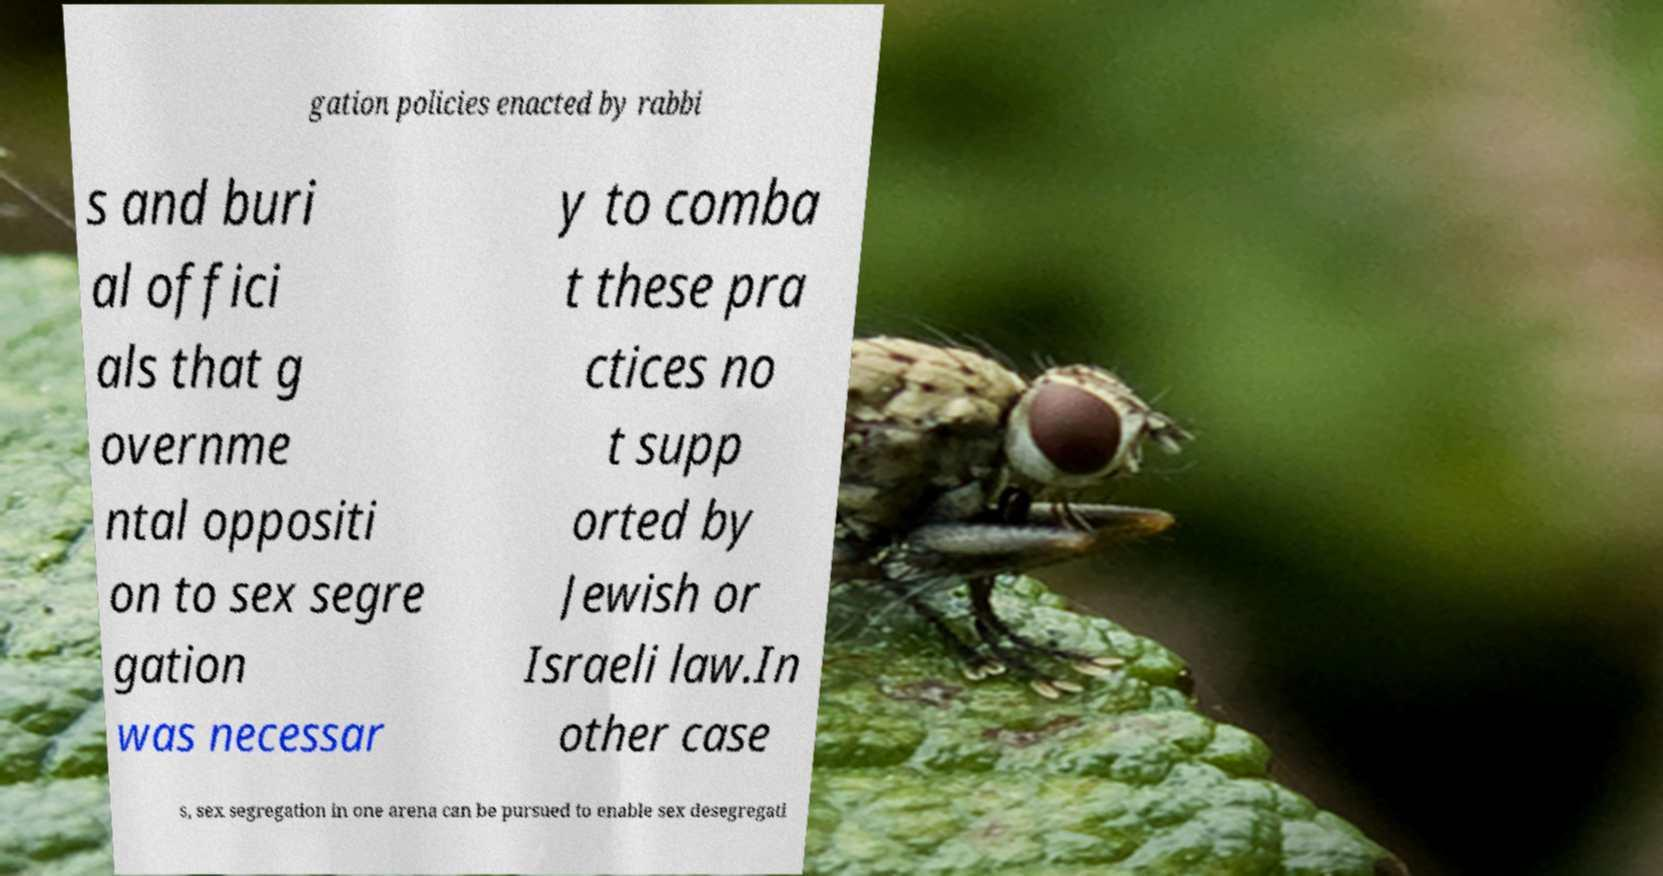Please read and relay the text visible in this image. What does it say? gation policies enacted by rabbi s and buri al offici als that g overnme ntal oppositi on to sex segre gation was necessar y to comba t these pra ctices no t supp orted by Jewish or Israeli law.In other case s, sex segregation in one arena can be pursued to enable sex desegregati 